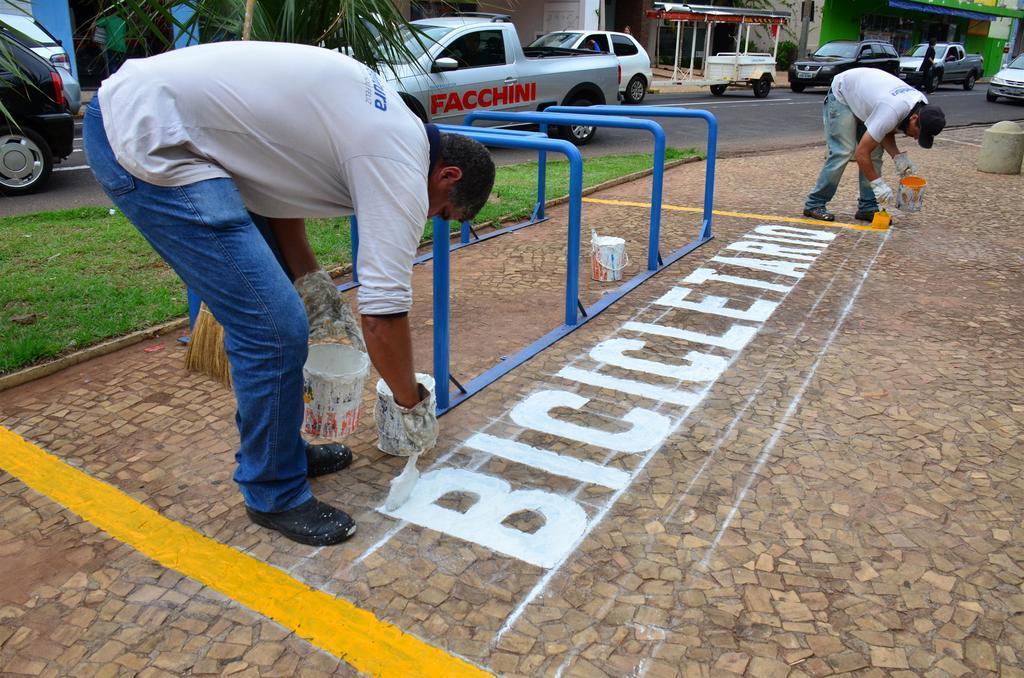In one or two sentences, can you explain what this image depicts? A picture of a street. Vehicles on road. These persons are holding a paint brush. Beside this person there is a paint bucket. These are stores. Grass is in green color. 